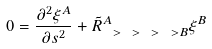Convert formula to latex. <formula><loc_0><loc_0><loc_500><loc_500>0 = \frac { \partial ^ { 2 } \xi ^ { A } } { \partial s ^ { 2 } } + \tilde { R } ^ { A } _ { \ > \ > \ > \ > B } \xi ^ { B }</formula> 